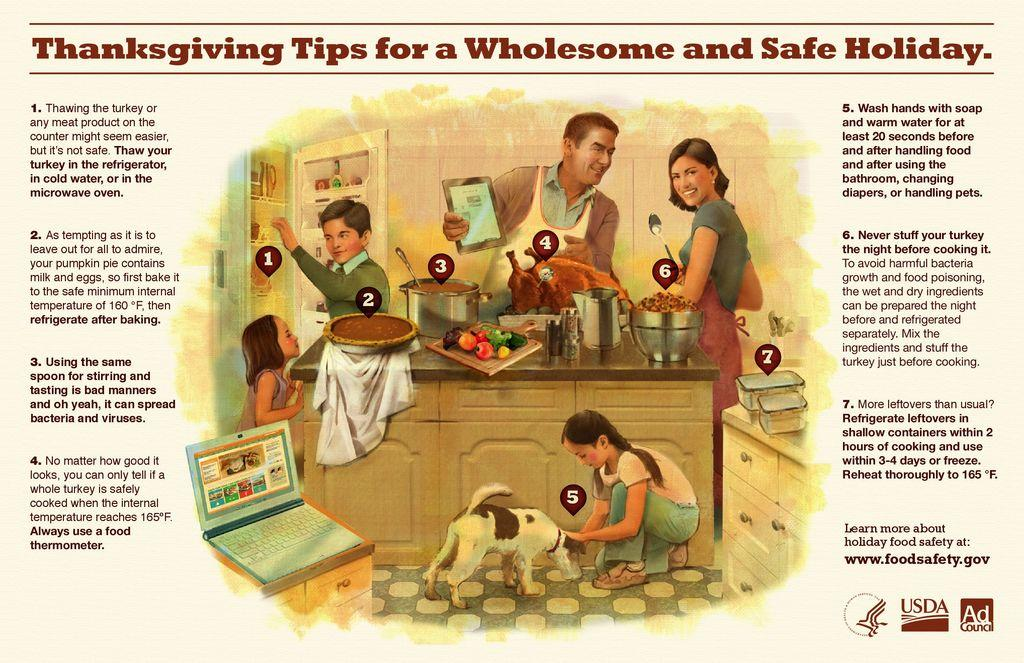<image>
Relay a brief, clear account of the picture shown. old usda poster for thanksgiving tips for a wholesome and safe holiday that shows a picture of a family in the kitchen 